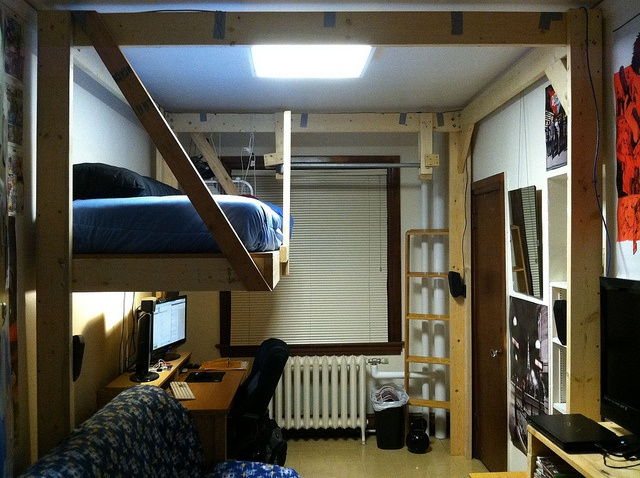Describe the objects in this image and their specific colors. I can see bed in black, navy, white, and darkblue tones, couch in black, gray, navy, and darkgreen tones, tv in black, olive, and khaki tones, chair in black, gray, olive, and blue tones, and tv in black, gray, darkgray, and white tones in this image. 